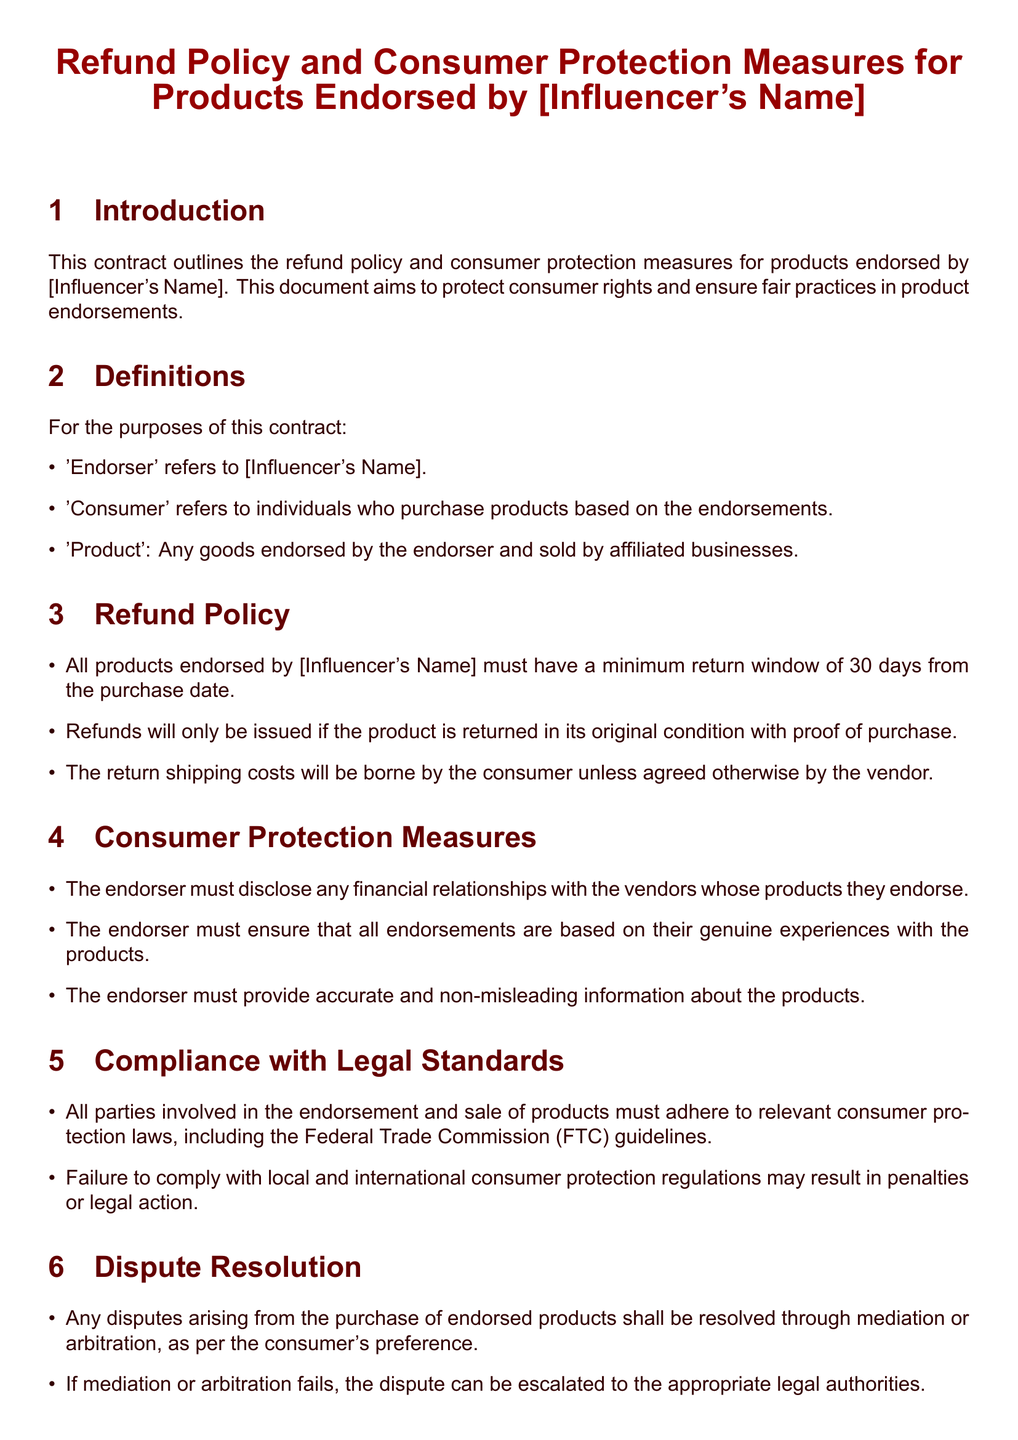what is the minimum return window for products? The document states that products must have a minimum return window of 30 days from the purchase date.
Answer: 30 days who is referred to as 'Endorser' in the document? The term 'Endorser' refers to the name of the influencer stated in the document.
Answer: [Influencer's Name] what must be included with a product return for a refund? A refund will only be issued if the product is returned in its original condition with proof of purchase.
Answer: proof of purchase what should the endorser disclose according to the consumer protection measures? The endorser must disclose any financial relationships with the vendors whose products they endorse.
Answer: financial relationships what happens if mediation or arbitration fails? If mediation or arbitration fails, the dispute can be escalated to the appropriate legal authorities.
Answer: escalated to legal authorities who can consumers contact for queries regarding the refund policy? Consumers can contact the support team associated with the influencer for queries regarding the refund policy.
Answer: [Influencer's Name] Support Team how can disputes arising from purchases be resolved? Disputes can be resolved through mediation or arbitration, as per the consumer's preference.
Answer: mediation or arbitration what relationship must the endorser have with the products they endorse? The endorser must ensure that all endorsements are based on their genuine experiences with the products.
Answer: genuine experiences 